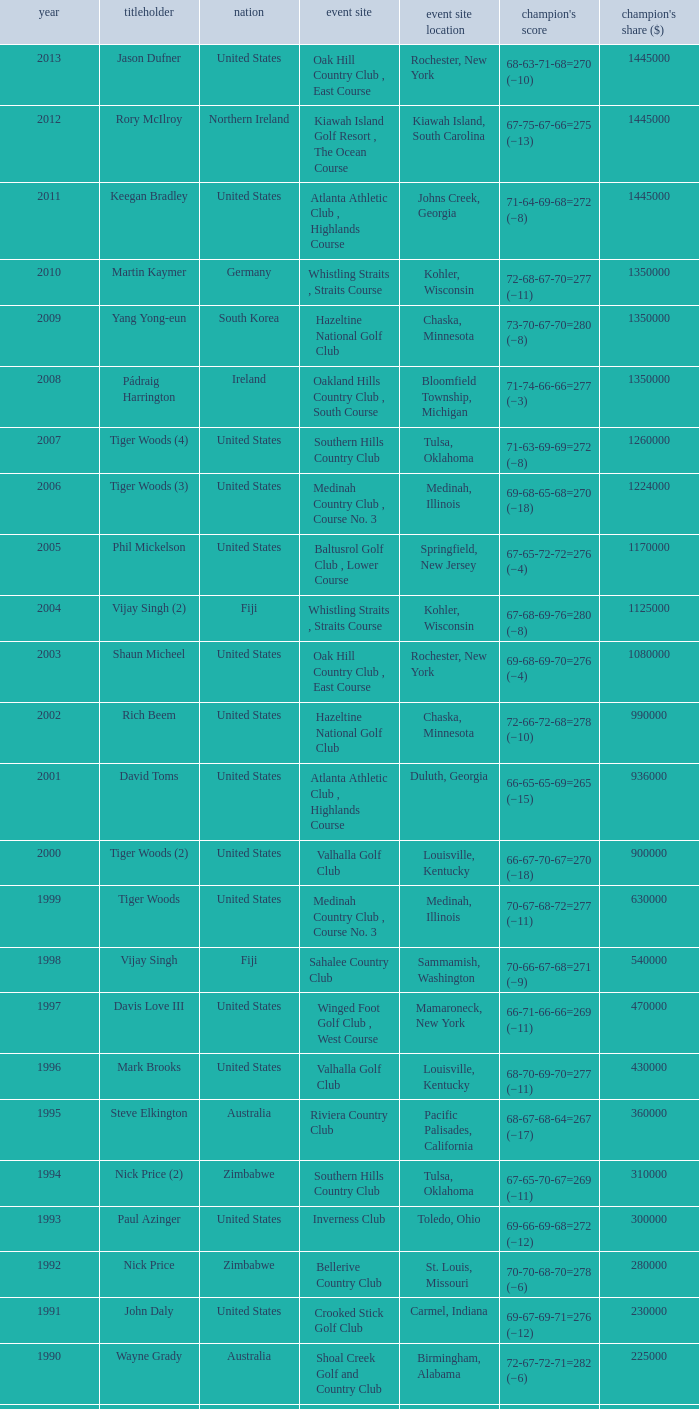List all winning scores from 1982. 63-69-68-72=272 (−8). 